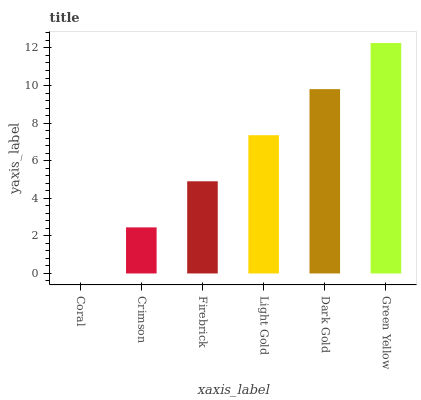Is Crimson the minimum?
Answer yes or no. No. Is Crimson the maximum?
Answer yes or no. No. Is Crimson greater than Coral?
Answer yes or no. Yes. Is Coral less than Crimson?
Answer yes or no. Yes. Is Coral greater than Crimson?
Answer yes or no. No. Is Crimson less than Coral?
Answer yes or no. No. Is Light Gold the high median?
Answer yes or no. Yes. Is Firebrick the low median?
Answer yes or no. Yes. Is Green Yellow the high median?
Answer yes or no. No. Is Crimson the low median?
Answer yes or no. No. 